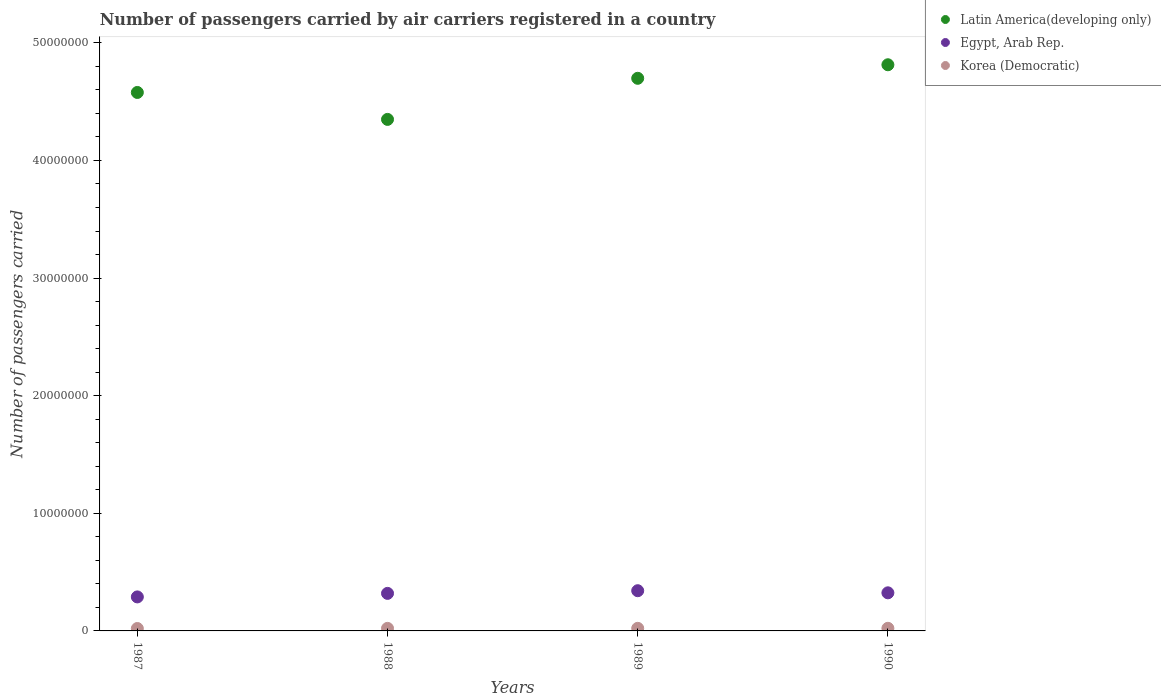How many different coloured dotlines are there?
Provide a short and direct response. 3. Is the number of dotlines equal to the number of legend labels?
Give a very brief answer. Yes. What is the number of passengers carried by air carriers in Egypt, Arab Rep. in 1987?
Give a very brief answer. 2.89e+06. Across all years, what is the maximum number of passengers carried by air carriers in Egypt, Arab Rep.?
Your response must be concise. 3.42e+06. Across all years, what is the minimum number of passengers carried by air carriers in Egypt, Arab Rep.?
Your answer should be compact. 2.89e+06. In which year was the number of passengers carried by air carriers in Latin America(developing only) maximum?
Give a very brief answer. 1990. What is the total number of passengers carried by air carriers in Egypt, Arab Rep. in the graph?
Keep it short and to the point. 1.27e+07. What is the difference between the number of passengers carried by air carriers in Egypt, Arab Rep. in 1987 and that in 1990?
Your answer should be compact. -3.48e+05. What is the difference between the number of passengers carried by air carriers in Latin America(developing only) in 1988 and the number of passengers carried by air carriers in Korea (Democratic) in 1990?
Your response must be concise. 4.33e+07. What is the average number of passengers carried by air carriers in Korea (Democratic) per year?
Offer a very short reply. 2.16e+05. In the year 1988, what is the difference between the number of passengers carried by air carriers in Latin America(developing only) and number of passengers carried by air carriers in Egypt, Arab Rep.?
Your answer should be compact. 4.03e+07. In how many years, is the number of passengers carried by air carriers in Egypt, Arab Rep. greater than 24000000?
Provide a succinct answer. 0. What is the ratio of the number of passengers carried by air carriers in Egypt, Arab Rep. in 1988 to that in 1989?
Make the answer very short. 0.93. What is the difference between the highest and the second highest number of passengers carried by air carriers in Egypt, Arab Rep.?
Your response must be concise. 1.79e+05. What is the difference between the highest and the lowest number of passengers carried by air carriers in Egypt, Arab Rep.?
Your answer should be very brief. 5.27e+05. Is the sum of the number of passengers carried by air carriers in Egypt, Arab Rep. in 1987 and 1989 greater than the maximum number of passengers carried by air carriers in Latin America(developing only) across all years?
Ensure brevity in your answer.  No. Is it the case that in every year, the sum of the number of passengers carried by air carriers in Latin America(developing only) and number of passengers carried by air carriers in Egypt, Arab Rep.  is greater than the number of passengers carried by air carriers in Korea (Democratic)?
Ensure brevity in your answer.  Yes. Does the number of passengers carried by air carriers in Latin America(developing only) monotonically increase over the years?
Your response must be concise. No. Is the number of passengers carried by air carriers in Egypt, Arab Rep. strictly less than the number of passengers carried by air carriers in Latin America(developing only) over the years?
Your response must be concise. Yes. Are the values on the major ticks of Y-axis written in scientific E-notation?
Provide a short and direct response. No. Does the graph contain any zero values?
Your answer should be very brief. No. Where does the legend appear in the graph?
Provide a succinct answer. Top right. How many legend labels are there?
Provide a succinct answer. 3. What is the title of the graph?
Your response must be concise. Number of passengers carried by air carriers registered in a country. Does "Azerbaijan" appear as one of the legend labels in the graph?
Ensure brevity in your answer.  No. What is the label or title of the Y-axis?
Ensure brevity in your answer.  Number of passengers carried. What is the Number of passengers carried in Latin America(developing only) in 1987?
Provide a short and direct response. 4.58e+07. What is the Number of passengers carried in Egypt, Arab Rep. in 1987?
Your response must be concise. 2.89e+06. What is the Number of passengers carried in Korea (Democratic) in 1987?
Offer a very short reply. 2.05e+05. What is the Number of passengers carried in Latin America(developing only) in 1988?
Ensure brevity in your answer.  4.35e+07. What is the Number of passengers carried in Egypt, Arab Rep. in 1988?
Your answer should be compact. 3.19e+06. What is the Number of passengers carried of Korea (Democratic) in 1988?
Provide a short and direct response. 2.18e+05. What is the Number of passengers carried in Latin America(developing only) in 1989?
Offer a terse response. 4.70e+07. What is the Number of passengers carried of Egypt, Arab Rep. in 1989?
Make the answer very short. 3.42e+06. What is the Number of passengers carried in Korea (Democratic) in 1989?
Provide a short and direct response. 2.20e+05. What is the Number of passengers carried in Latin America(developing only) in 1990?
Provide a short and direct response. 4.81e+07. What is the Number of passengers carried in Egypt, Arab Rep. in 1990?
Your answer should be compact. 3.24e+06. What is the Number of passengers carried in Korea (Democratic) in 1990?
Keep it short and to the point. 2.23e+05. Across all years, what is the maximum Number of passengers carried in Latin America(developing only)?
Make the answer very short. 4.81e+07. Across all years, what is the maximum Number of passengers carried in Egypt, Arab Rep.?
Provide a short and direct response. 3.42e+06. Across all years, what is the maximum Number of passengers carried in Korea (Democratic)?
Offer a terse response. 2.23e+05. Across all years, what is the minimum Number of passengers carried of Latin America(developing only)?
Ensure brevity in your answer.  4.35e+07. Across all years, what is the minimum Number of passengers carried of Egypt, Arab Rep.?
Ensure brevity in your answer.  2.89e+06. Across all years, what is the minimum Number of passengers carried of Korea (Democratic)?
Your answer should be very brief. 2.05e+05. What is the total Number of passengers carried of Latin America(developing only) in the graph?
Make the answer very short. 1.84e+08. What is the total Number of passengers carried of Egypt, Arab Rep. in the graph?
Give a very brief answer. 1.27e+07. What is the total Number of passengers carried in Korea (Democratic) in the graph?
Your response must be concise. 8.66e+05. What is the difference between the Number of passengers carried of Latin America(developing only) in 1987 and that in 1988?
Offer a very short reply. 2.29e+06. What is the difference between the Number of passengers carried in Egypt, Arab Rep. in 1987 and that in 1988?
Your response must be concise. -3.01e+05. What is the difference between the Number of passengers carried of Korea (Democratic) in 1987 and that in 1988?
Your response must be concise. -1.25e+04. What is the difference between the Number of passengers carried of Latin America(developing only) in 1987 and that in 1989?
Your response must be concise. -1.20e+06. What is the difference between the Number of passengers carried of Egypt, Arab Rep. in 1987 and that in 1989?
Ensure brevity in your answer.  -5.27e+05. What is the difference between the Number of passengers carried of Korea (Democratic) in 1987 and that in 1989?
Provide a short and direct response. -1.54e+04. What is the difference between the Number of passengers carried in Latin America(developing only) in 1987 and that in 1990?
Your answer should be very brief. -2.35e+06. What is the difference between the Number of passengers carried of Egypt, Arab Rep. in 1987 and that in 1990?
Offer a terse response. -3.48e+05. What is the difference between the Number of passengers carried of Korea (Democratic) in 1987 and that in 1990?
Make the answer very short. -1.77e+04. What is the difference between the Number of passengers carried in Latin America(developing only) in 1988 and that in 1989?
Give a very brief answer. -3.49e+06. What is the difference between the Number of passengers carried of Egypt, Arab Rep. in 1988 and that in 1989?
Your response must be concise. -2.26e+05. What is the difference between the Number of passengers carried of Korea (Democratic) in 1988 and that in 1989?
Give a very brief answer. -2900. What is the difference between the Number of passengers carried in Latin America(developing only) in 1988 and that in 1990?
Your response must be concise. -4.65e+06. What is the difference between the Number of passengers carried in Egypt, Arab Rep. in 1988 and that in 1990?
Your answer should be very brief. -4.71e+04. What is the difference between the Number of passengers carried in Korea (Democratic) in 1988 and that in 1990?
Offer a very short reply. -5200. What is the difference between the Number of passengers carried in Latin America(developing only) in 1989 and that in 1990?
Keep it short and to the point. -1.15e+06. What is the difference between the Number of passengers carried of Egypt, Arab Rep. in 1989 and that in 1990?
Ensure brevity in your answer.  1.79e+05. What is the difference between the Number of passengers carried of Korea (Democratic) in 1989 and that in 1990?
Make the answer very short. -2300. What is the difference between the Number of passengers carried in Latin America(developing only) in 1987 and the Number of passengers carried in Egypt, Arab Rep. in 1988?
Offer a terse response. 4.26e+07. What is the difference between the Number of passengers carried in Latin America(developing only) in 1987 and the Number of passengers carried in Korea (Democratic) in 1988?
Offer a very short reply. 4.56e+07. What is the difference between the Number of passengers carried in Egypt, Arab Rep. in 1987 and the Number of passengers carried in Korea (Democratic) in 1988?
Your answer should be very brief. 2.67e+06. What is the difference between the Number of passengers carried in Latin America(developing only) in 1987 and the Number of passengers carried in Egypt, Arab Rep. in 1989?
Provide a succinct answer. 4.24e+07. What is the difference between the Number of passengers carried of Latin America(developing only) in 1987 and the Number of passengers carried of Korea (Democratic) in 1989?
Offer a very short reply. 4.56e+07. What is the difference between the Number of passengers carried of Egypt, Arab Rep. in 1987 and the Number of passengers carried of Korea (Democratic) in 1989?
Provide a succinct answer. 2.67e+06. What is the difference between the Number of passengers carried in Latin America(developing only) in 1987 and the Number of passengers carried in Egypt, Arab Rep. in 1990?
Provide a succinct answer. 4.25e+07. What is the difference between the Number of passengers carried of Latin America(developing only) in 1987 and the Number of passengers carried of Korea (Democratic) in 1990?
Your answer should be compact. 4.56e+07. What is the difference between the Number of passengers carried of Egypt, Arab Rep. in 1987 and the Number of passengers carried of Korea (Democratic) in 1990?
Provide a short and direct response. 2.67e+06. What is the difference between the Number of passengers carried in Latin America(developing only) in 1988 and the Number of passengers carried in Egypt, Arab Rep. in 1989?
Give a very brief answer. 4.01e+07. What is the difference between the Number of passengers carried of Latin America(developing only) in 1988 and the Number of passengers carried of Korea (Democratic) in 1989?
Keep it short and to the point. 4.33e+07. What is the difference between the Number of passengers carried in Egypt, Arab Rep. in 1988 and the Number of passengers carried in Korea (Democratic) in 1989?
Give a very brief answer. 2.97e+06. What is the difference between the Number of passengers carried in Latin America(developing only) in 1988 and the Number of passengers carried in Egypt, Arab Rep. in 1990?
Ensure brevity in your answer.  4.03e+07. What is the difference between the Number of passengers carried in Latin America(developing only) in 1988 and the Number of passengers carried in Korea (Democratic) in 1990?
Give a very brief answer. 4.33e+07. What is the difference between the Number of passengers carried in Egypt, Arab Rep. in 1988 and the Number of passengers carried in Korea (Democratic) in 1990?
Your answer should be very brief. 2.97e+06. What is the difference between the Number of passengers carried in Latin America(developing only) in 1989 and the Number of passengers carried in Egypt, Arab Rep. in 1990?
Offer a terse response. 4.37e+07. What is the difference between the Number of passengers carried in Latin America(developing only) in 1989 and the Number of passengers carried in Korea (Democratic) in 1990?
Provide a short and direct response. 4.68e+07. What is the difference between the Number of passengers carried in Egypt, Arab Rep. in 1989 and the Number of passengers carried in Korea (Democratic) in 1990?
Your response must be concise. 3.20e+06. What is the average Number of passengers carried of Latin America(developing only) per year?
Your response must be concise. 4.61e+07. What is the average Number of passengers carried of Egypt, Arab Rep. per year?
Your response must be concise. 3.19e+06. What is the average Number of passengers carried in Korea (Democratic) per year?
Make the answer very short. 2.16e+05. In the year 1987, what is the difference between the Number of passengers carried of Latin America(developing only) and Number of passengers carried of Egypt, Arab Rep.?
Provide a short and direct response. 4.29e+07. In the year 1987, what is the difference between the Number of passengers carried of Latin America(developing only) and Number of passengers carried of Korea (Democratic)?
Your answer should be very brief. 4.56e+07. In the year 1987, what is the difference between the Number of passengers carried of Egypt, Arab Rep. and Number of passengers carried of Korea (Democratic)?
Offer a very short reply. 2.69e+06. In the year 1988, what is the difference between the Number of passengers carried of Latin America(developing only) and Number of passengers carried of Egypt, Arab Rep.?
Give a very brief answer. 4.03e+07. In the year 1988, what is the difference between the Number of passengers carried in Latin America(developing only) and Number of passengers carried in Korea (Democratic)?
Provide a succinct answer. 4.33e+07. In the year 1988, what is the difference between the Number of passengers carried of Egypt, Arab Rep. and Number of passengers carried of Korea (Democratic)?
Your response must be concise. 2.97e+06. In the year 1989, what is the difference between the Number of passengers carried of Latin America(developing only) and Number of passengers carried of Egypt, Arab Rep.?
Make the answer very short. 4.36e+07. In the year 1989, what is the difference between the Number of passengers carried in Latin America(developing only) and Number of passengers carried in Korea (Democratic)?
Your response must be concise. 4.68e+07. In the year 1989, what is the difference between the Number of passengers carried of Egypt, Arab Rep. and Number of passengers carried of Korea (Democratic)?
Provide a succinct answer. 3.20e+06. In the year 1990, what is the difference between the Number of passengers carried in Latin America(developing only) and Number of passengers carried in Egypt, Arab Rep.?
Give a very brief answer. 4.49e+07. In the year 1990, what is the difference between the Number of passengers carried of Latin America(developing only) and Number of passengers carried of Korea (Democratic)?
Your answer should be very brief. 4.79e+07. In the year 1990, what is the difference between the Number of passengers carried in Egypt, Arab Rep. and Number of passengers carried in Korea (Democratic)?
Keep it short and to the point. 3.02e+06. What is the ratio of the Number of passengers carried of Latin America(developing only) in 1987 to that in 1988?
Give a very brief answer. 1.05. What is the ratio of the Number of passengers carried in Egypt, Arab Rep. in 1987 to that in 1988?
Ensure brevity in your answer.  0.91. What is the ratio of the Number of passengers carried in Korea (Democratic) in 1987 to that in 1988?
Your answer should be very brief. 0.94. What is the ratio of the Number of passengers carried in Latin America(developing only) in 1987 to that in 1989?
Keep it short and to the point. 0.97. What is the ratio of the Number of passengers carried of Egypt, Arab Rep. in 1987 to that in 1989?
Ensure brevity in your answer.  0.85. What is the ratio of the Number of passengers carried in Korea (Democratic) in 1987 to that in 1989?
Keep it short and to the point. 0.93. What is the ratio of the Number of passengers carried of Latin America(developing only) in 1987 to that in 1990?
Your response must be concise. 0.95. What is the ratio of the Number of passengers carried of Egypt, Arab Rep. in 1987 to that in 1990?
Ensure brevity in your answer.  0.89. What is the ratio of the Number of passengers carried of Korea (Democratic) in 1987 to that in 1990?
Provide a short and direct response. 0.92. What is the ratio of the Number of passengers carried of Latin America(developing only) in 1988 to that in 1989?
Give a very brief answer. 0.93. What is the ratio of the Number of passengers carried of Egypt, Arab Rep. in 1988 to that in 1989?
Your answer should be very brief. 0.93. What is the ratio of the Number of passengers carried in Korea (Democratic) in 1988 to that in 1989?
Ensure brevity in your answer.  0.99. What is the ratio of the Number of passengers carried of Latin America(developing only) in 1988 to that in 1990?
Make the answer very short. 0.9. What is the ratio of the Number of passengers carried in Egypt, Arab Rep. in 1988 to that in 1990?
Keep it short and to the point. 0.99. What is the ratio of the Number of passengers carried in Korea (Democratic) in 1988 to that in 1990?
Your answer should be compact. 0.98. What is the ratio of the Number of passengers carried in Latin America(developing only) in 1989 to that in 1990?
Provide a short and direct response. 0.98. What is the ratio of the Number of passengers carried in Egypt, Arab Rep. in 1989 to that in 1990?
Your answer should be compact. 1.06. What is the ratio of the Number of passengers carried of Korea (Democratic) in 1989 to that in 1990?
Your response must be concise. 0.99. What is the difference between the highest and the second highest Number of passengers carried in Latin America(developing only)?
Provide a short and direct response. 1.15e+06. What is the difference between the highest and the second highest Number of passengers carried in Egypt, Arab Rep.?
Your answer should be compact. 1.79e+05. What is the difference between the highest and the second highest Number of passengers carried in Korea (Democratic)?
Offer a terse response. 2300. What is the difference between the highest and the lowest Number of passengers carried in Latin America(developing only)?
Your answer should be compact. 4.65e+06. What is the difference between the highest and the lowest Number of passengers carried in Egypt, Arab Rep.?
Give a very brief answer. 5.27e+05. What is the difference between the highest and the lowest Number of passengers carried in Korea (Democratic)?
Offer a very short reply. 1.77e+04. 